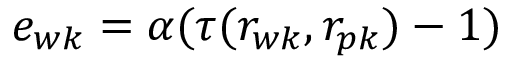Convert formula to latex. <formula><loc_0><loc_0><loc_500><loc_500>e _ { w k } = \alpha ( \tau ( r _ { w k } , r _ { p k } ) - 1 )</formula> 